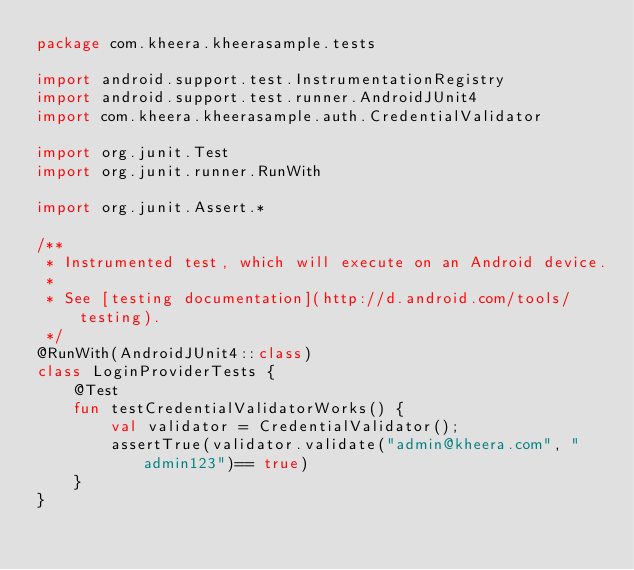<code> <loc_0><loc_0><loc_500><loc_500><_Kotlin_>package com.kheera.kheerasample.tests

import android.support.test.InstrumentationRegistry
import android.support.test.runner.AndroidJUnit4
import com.kheera.kheerasample.auth.CredentialValidator

import org.junit.Test
import org.junit.runner.RunWith

import org.junit.Assert.*

/**
 * Instrumented test, which will execute on an Android device.
 *
 * See [testing documentation](http://d.android.com/tools/testing).
 */
@RunWith(AndroidJUnit4::class)
class LoginProviderTests {
    @Test
    fun testCredentialValidatorWorks() {
        val validator = CredentialValidator();
        assertTrue(validator.validate("admin@kheera.com", "admin123")== true)
    }
}
</code> 